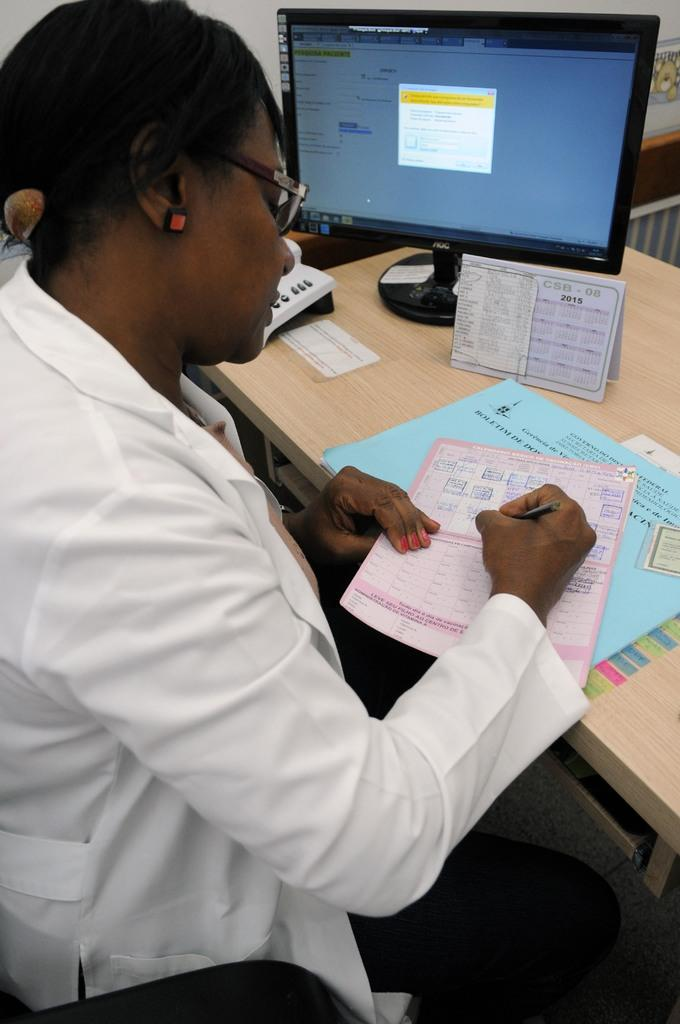Provide a one-sentence caption for the provided image. a man writing at a desk  next to a blue paper that says 'boletim' on it. 